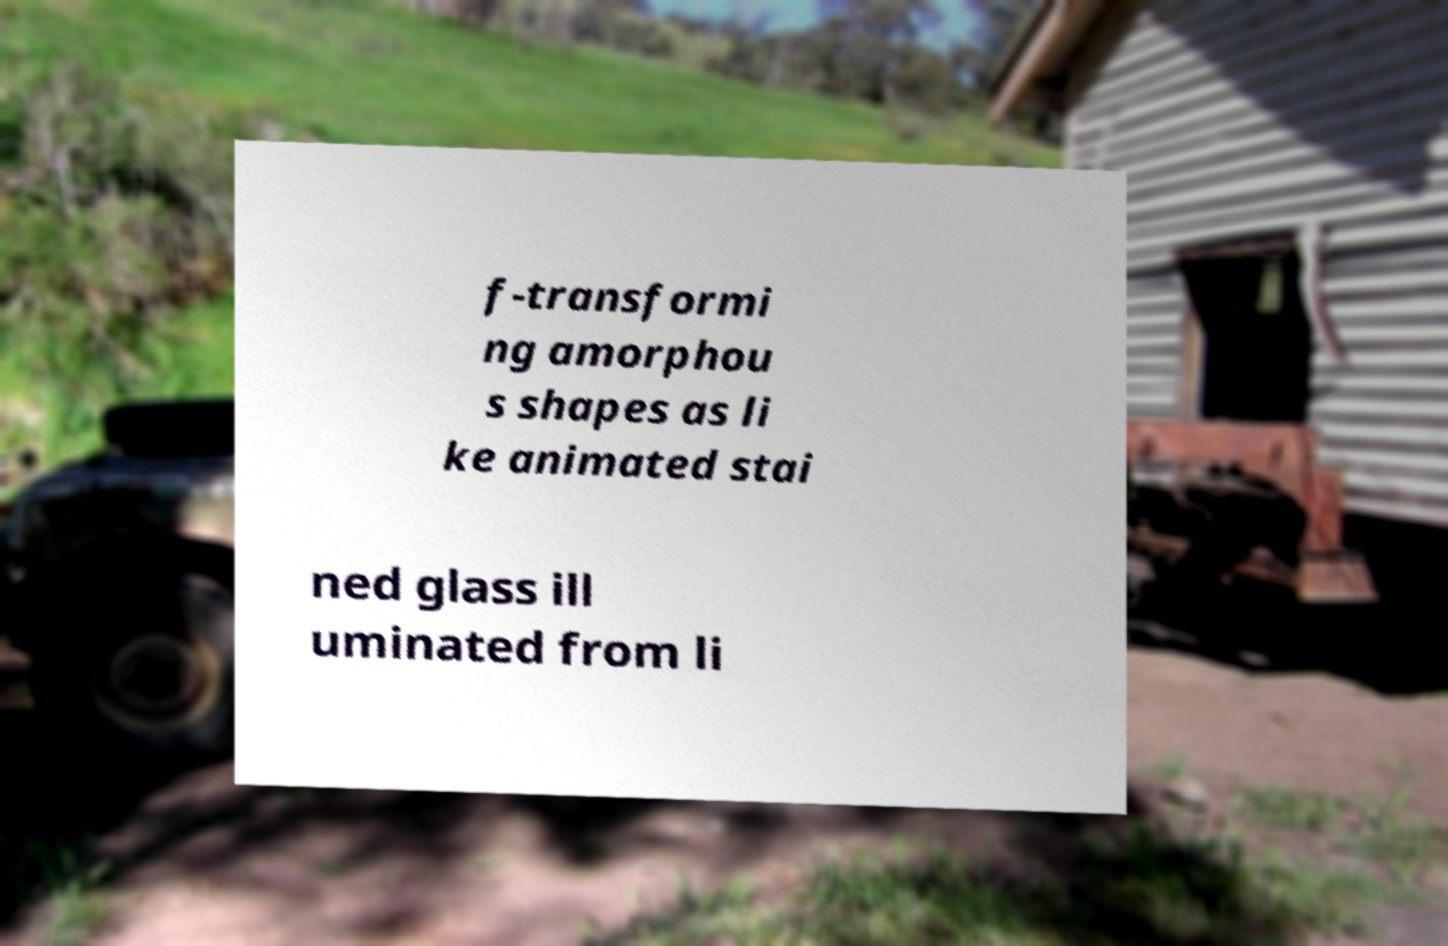There's text embedded in this image that I need extracted. Can you transcribe it verbatim? f-transformi ng amorphou s shapes as li ke animated stai ned glass ill uminated from li 